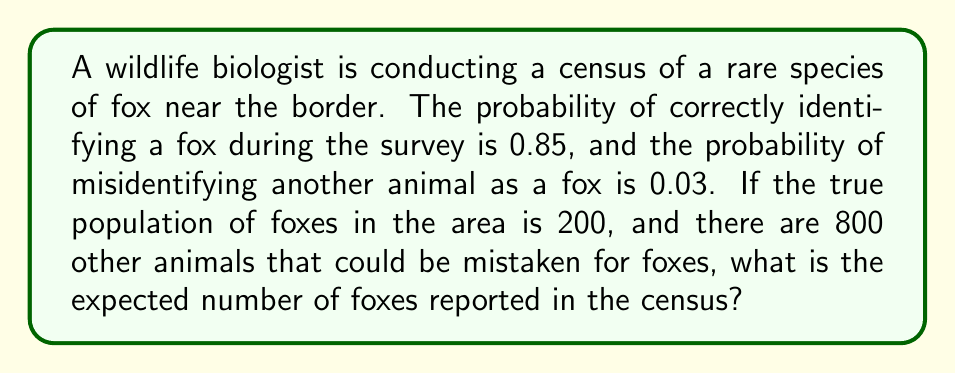Help me with this question. To solve this problem, we need to use concepts from probability theory and expected value. Let's break it down step-by-step:

1. Define the variables:
   - $p_c = 0.85$ (probability of correctly identifying a fox)
   - $p_m = 0.03$ (probability of misidentifying another animal as a fox)
   - $N_f = 200$ (true number of foxes)
   - $N_o = 800$ (number of other animals)

2. Calculate the expected number of correctly identified foxes:
   $$E(\text{correct}) = N_f \cdot p_c = 200 \cdot 0.85 = 170$$

3. Calculate the expected number of misidentified animals:
   $$E(\text{misidentified}) = N_o \cdot p_m = 800 \cdot 0.03 = 24$$

4. The total expected number of reported foxes is the sum of correctly identified foxes and misidentified animals:
   $$E(\text{total}) = E(\text{correct}) + E(\text{misidentified}) = 170 + 24 = 194$$

This result shows that even though the true population is 200 foxes, the expected number of foxes reported in the census is 194 due to the combined effects of missed identifications and false positives.
Answer: 194 foxes 